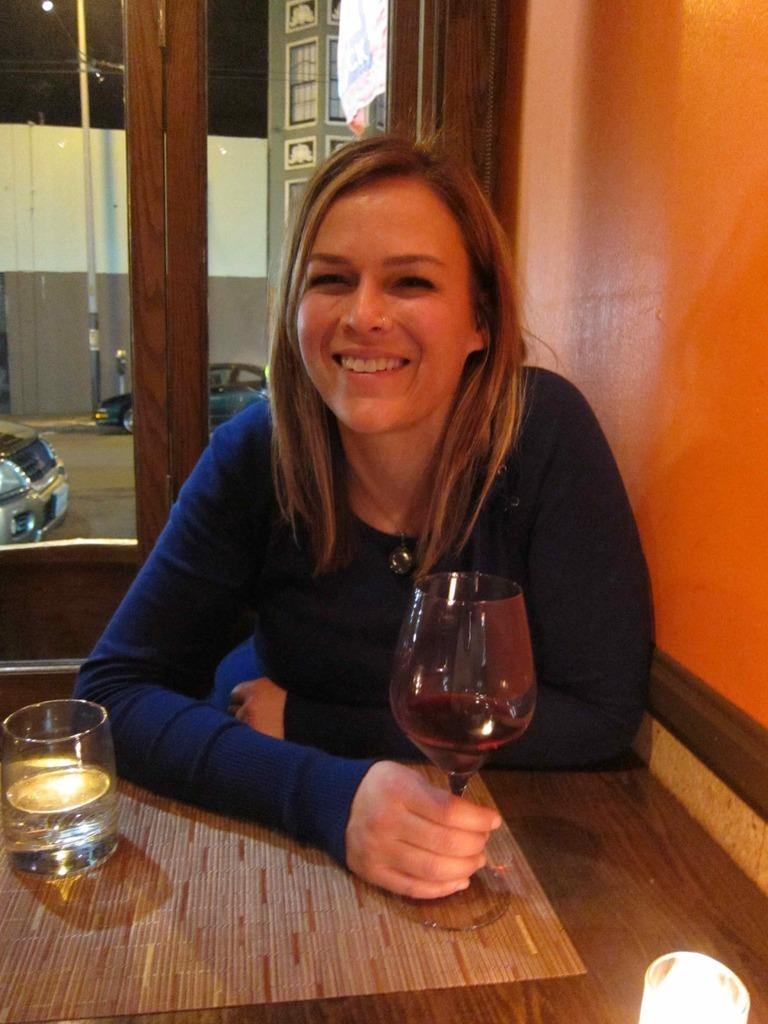Who is present in the image? There is a woman in the image. What is the woman doing in the image? The woman is seated on a chair. What is the woman holding in her hand? The woman is holding a wine glass in her hand. What other object can be seen on the table in the image? There is a glass on the table in the image. What holiday is the woman celebrating in the image? There is no indication of a holiday in the image; it simply shows a woman seated on a chair holding a wine glass. 